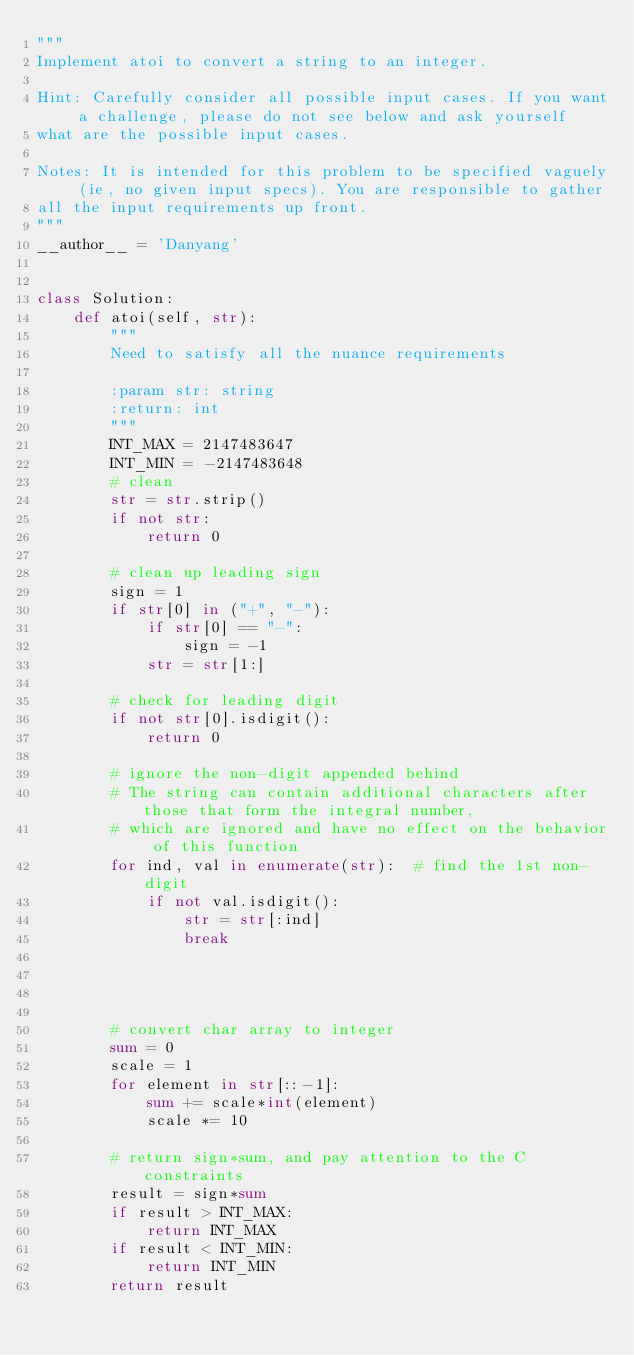Convert code to text. <code><loc_0><loc_0><loc_500><loc_500><_Python_>"""
Implement atoi to convert a string to an integer.

Hint: Carefully consider all possible input cases. If you want a challenge, please do not see below and ask yourself
what are the possible input cases.

Notes: It is intended for this problem to be specified vaguely (ie, no given input specs). You are responsible to gather
all the input requirements up front.
"""
__author__ = 'Danyang'


class Solution:
    def atoi(self, str):
        """
        Need to satisfy all the nuance requirements

        :param str: string
        :return: int
        """
        INT_MAX = 2147483647
        INT_MIN = -2147483648
        # clean
        str = str.strip()
        if not str:
            return 0

        # clean up leading sign
        sign = 1
        if str[0] in ("+", "-"):
            if str[0] == "-":
                sign = -1
            str = str[1:]

        # check for leading digit
        if not str[0].isdigit():
            return 0

        # ignore the non-digit appended behind
        # The string can contain additional characters after those that form the integral number,
        # which are ignored and have no effect on the behavior of this function
        for ind, val in enumerate(str):  # find the 1st non-digit
            if not val.isdigit():
                str = str[:ind]
                break




        # convert char array to integer
        sum = 0
        scale = 1
        for element in str[::-1]:
            sum += scale*int(element)
            scale *= 10

        # return sign*sum, and pay attention to the C constraints
        result = sign*sum
        if result > INT_MAX:
            return INT_MAX
        if result < INT_MIN:
            return INT_MIN
        return result
</code> 